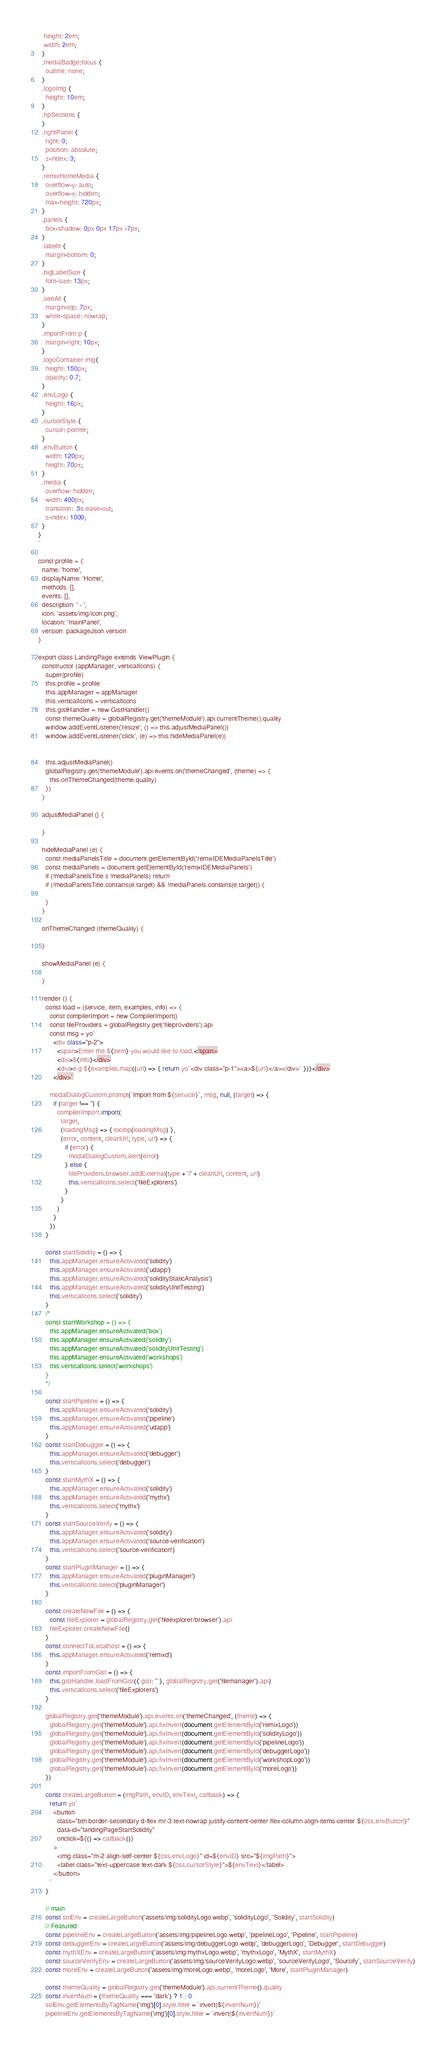Convert code to text. <code><loc_0><loc_0><loc_500><loc_500><_JavaScript_>   height: 2em;
   width: 2em;
  }
  .mediaBadge:focus {
    outline: none;
  }
  .logoImg {
    height: 10em;
  }
  .hpSections {
  }
  .rightPanel {
    right: 0;
    position: absolute;
    z-index: 3;
  }
  .remixHomeMedia {
    overflow-y: auto;
    overflow-x: hidden;
    max-height: 720px;
  }
  .panels {
    box-shadow: 0px 0px 17px -7px;
  }
  .labelIt {
    margin-bottom: 0;
  }
  .bigLabelSize {
    font-size: 13px;
  }
  .seeAll {
    margin-top: 7px;
    white-space: nowrap;
  }
  .importFrom p {
    margin-right: 10px;
  }
  .logoContainer img{
    height: 150px;
    opacity: 0.7;
  }
  .envLogo {
    height: 16px;
  }
  .cursorStyle {
    cursor: pointer;
  }
  .envButton {
    width: 120px;
    height: 70px;
  }
  .media {
    overflow: hidden;
    width: 400px;
    transition: .5s ease-out;
    z-index: 1000;
  }
}
`

const profile = {
  name: 'home',
  displayName: 'Home',
  methods: [],
  events: [],
  description: ' - ',
  icon: 'assets/img/icon.png',
  location: 'mainPanel',
  version: packageJson.version
}

export class LandingPage extends ViewPlugin {
  constructor (appManager, verticalIcons) {
    super(profile)
    this.profile = profile
    this.appManager = appManager
    this.verticalIcons = verticalIcons
    this.gistHandler = new GistHandler()
    const themeQuality = globalRegistry.get('themeModule').api.currentTheme().quality
    window.addEventListener('resize', () => this.adjustMediaPanel())
    window.addEventListener('click', (e) => this.hideMediaPanel(e))
    
   
    this.adjustMediaPanel()
    globalRegistry.get('themeModule').api.events.on('themeChanged', (theme) => {
      this.onThemeChanged(theme.quality)
    })
  }

  adjustMediaPanel () {
    
  }

  hideMediaPanel (e) {
    const mediaPanelsTitle = document.getElementById('remixIDEMediaPanelsTitle')
    const mediaPanels = document.getElementById('remixIDEMediaPanels')
    if (!mediaPanelsTitle || !mediaPanels) return
    if (!mediaPanelsTitle.contains(e.target) && !mediaPanels.contains(e.target)) {
     
    }
  }

  onThemeChanged (themeQuality) {
   
  }

  showMediaPanel (e) {
    
  }

  render () {
    const load = (service, item, examples, info) => {
      const compilerImport = new CompilerImport()
      const fileProviders = globalRegistry.get('fileproviders').api
      const msg = yo`
        <div class="p-2">
          <span>Enter the ${item} you would like to load.</span>
          <div>${info}</div>
          <div>e.g ${examples.map((url) => { return yo`<div class="p-1"><a>${url}</a></div>` })}</div>
        </div>`

      modalDialogCustom.prompt(`Import from ${service}`, msg, null, (target) => {
        if (target !== '') {
          compilerImport.import(
            target,
            (loadingMsg) => { tooltip(loadingMsg) },
            (error, content, cleanUrl, type, url) => {
              if (error) {
                modalDialogCustom.alert(error)
              } else {
                fileProviders.browser.addExternal(type + '/' + cleanUrl, content, url)
                this.verticalIcons.select('fileExplorers')
              }
            }
          )
        }
      })
    }

    const startSolidity = () => {
      this.appManager.ensureActivated('solidity')
      this.appManager.ensureActivated('udapp')
      this.appManager.ensureActivated('solidityStaticAnalysis')
      this.appManager.ensureActivated('solidityUnitTesting')
      this.verticalIcons.select('solidity')
    }
    /*
    const startWorkshop = () => {
      this.appManager.ensureActivated('box')
      this.appManager.ensureActivated('solidity')
      this.appManager.ensureActivated('solidityUnitTesting')
      this.appManager.ensureActivated('workshops')
      this.verticalIcons.select('workshops')
    }
    */

    const startPipeline = () => {
      this.appManager.ensureActivated('solidity')
      this.appManager.ensureActivated('pipeline')
      this.appManager.ensureActivated('udapp')
    }
    const startDebugger = () => {
      this.appManager.ensureActivated('debugger')
      this.verticalIcons.select('debugger')
    }
    const startMythX = () => {
      this.appManager.ensureActivated('solidity')
      this.appManager.ensureActivated('mythx')
      this.verticalIcons.select('mythx')
    }
    const startSourceVerify = () => {
      this.appManager.ensureActivated('solidity')
      this.appManager.ensureActivated('source-verification')
      this.verticalIcons.select('source-verification')
    }
    const startPluginManager = () => {
      this.appManager.ensureActivated('pluginManager')
      this.verticalIcons.select('pluginManager')
    }

    const createNewFile = () => {
      const fileExplorer = globalRegistry.get('fileexplorer/browser').api
      fileExplorer.createNewFile()
    }
    const connectToLocalhost = () => {
      this.appManager.ensureActivated('remixd')
    }
    const importFromGist = () => {
      this.gistHandler.loadFromGist({ gist: '' }, globalRegistry.get('filemanager').api)
      this.verticalIcons.select('fileExplorers')
    }

    globalRegistry.get('themeModule').api.events.on('themeChanged', (theme) => {
      globalRegistry.get('themeModule').api.fixInvert(document.getElementById('remixLogo'))
      globalRegistry.get('themeModule').api.fixInvert(document.getElementById('solidityLogo'))
      globalRegistry.get('themeModule').api.fixInvert(document.getElementById('pipelineLogo'))
      globalRegistry.get('themeModule').api.fixInvert(document.getElementById('debuggerLogo'))
      globalRegistry.get('themeModule').api.fixInvert(document.getElementById('workshopLogo'))
      globalRegistry.get('themeModule').api.fixInvert(document.getElementById('moreLogo'))
    })

    const createLargeButton = (imgPath, envID, envText, callback) => {
      return yo`
        <button
          class="btn border-secondary d-flex mr-3 text-nowrap justify-content-center flex-column align-items-center ${css.envButton}"
          data-id="landingPageStartSolidity"
          onclick=${() => callback()}
        >
          <img class="m-2 align-self-center ${css.envLogo}" id=${envID} src="${imgPath}">
          <label class="text-uppercase text-dark ${css.cursorStyle}">${envText}</label>
        </button>
      `
    }

    // main
    const solEnv = createLargeButton('assets/img/solidityLogo.webp', 'solidityLogo', 'Solidity', startSolidity)
    // Featured
    const pipelineEnv = createLargeButton('assets/img/pipelineLogo.webp', 'pipelineLogo', 'Pipeline', startPipeline)
    const debuggerEnv = createLargeButton('assets/img/debuggerLogo.webp', 'debuggerLogo', 'Debugger', startDebugger)
    const mythXEnv = createLargeButton('assets/img/mythxLogo.webp', 'mythxLogo', 'MythX', startMythX)
    const sourceVerifyEnv = createLargeButton('assets/img/sourceVerifyLogo.webp', 'sourceVerifyLogo', 'Sourcify', startSourceVerify)
    const moreEnv = createLargeButton('assets/img/moreLogo.webp', 'moreLogo', 'More', startPluginManager)

    const themeQuality = globalRegistry.get('themeModule').api.currentTheme().quality
    const invertNum = (themeQuality === 'dark') ? 1 : 0
    solEnv.getElementsByTagName('img')[0].style.filter = `invert(${invertNum})`
    pipelineEnv.getElementsByTagName('img')[0].style.filter = `invert(${invertNum})`</code> 